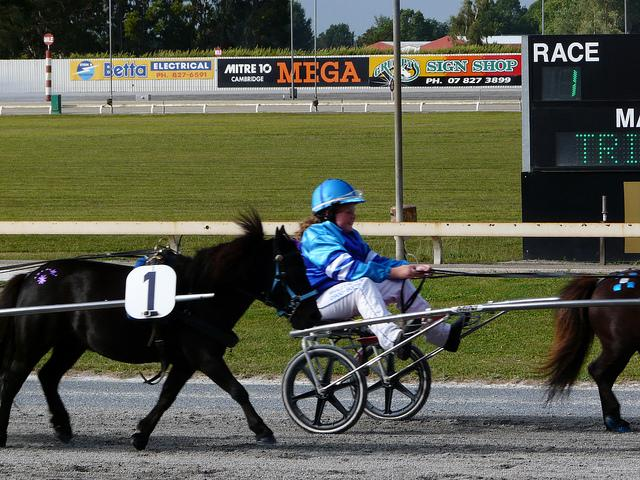What is this activity?

Choices:
A) musical
B) play
C) race
D) concert race 